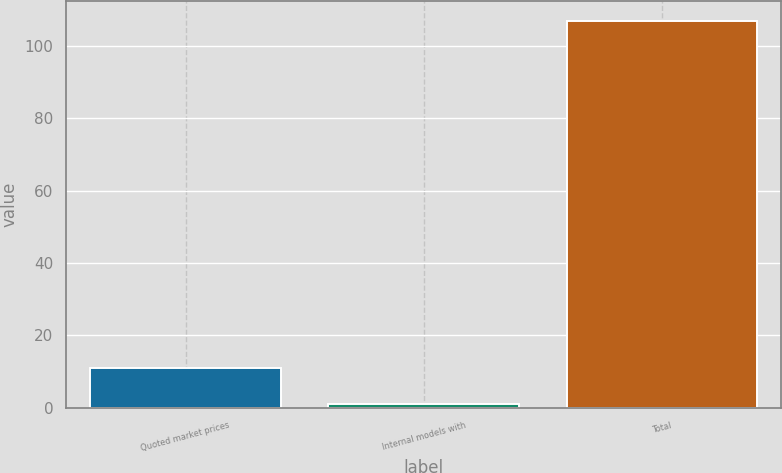Convert chart to OTSL. <chart><loc_0><loc_0><loc_500><loc_500><bar_chart><fcel>Quoted market prices<fcel>Internal models with<fcel>Total<nl><fcel>10.9<fcel>1<fcel>106.9<nl></chart> 